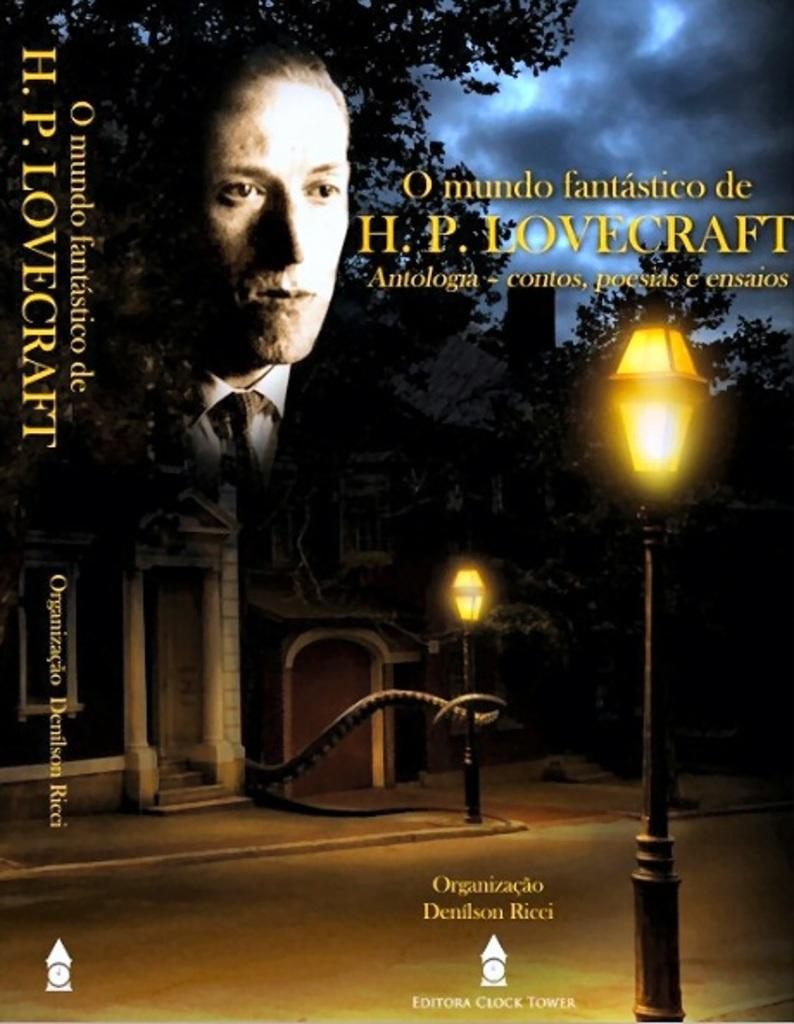<image>
Create a compact narrative representing the image presented. A poster that says O mundo fantastico de HP LOVECRAFT 